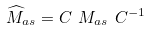<formula> <loc_0><loc_0><loc_500><loc_500>\widehat { M } _ { a s } = C \ M _ { a s } \ C ^ { - 1 }</formula> 